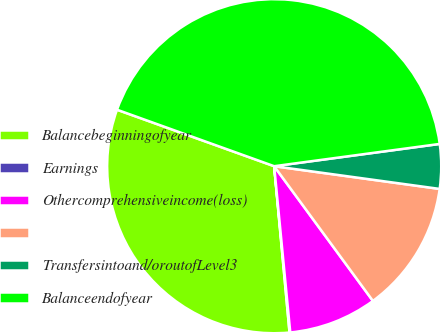Convert chart to OTSL. <chart><loc_0><loc_0><loc_500><loc_500><pie_chart><fcel>Balancebeginningofyear<fcel>Earnings<fcel>Othercomprehensiveincome(loss)<fcel>Unnamed: 3<fcel>Transfersintoand/oroutofLevel3<fcel>Balanceendofyear<nl><fcel>31.95%<fcel>0.07%<fcel>8.53%<fcel>12.76%<fcel>4.3%<fcel>42.37%<nl></chart> 